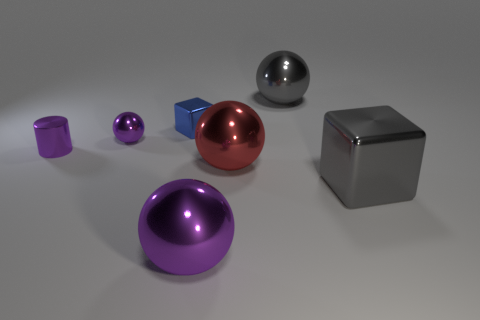What material is the gray thing that is the same shape as the large purple metallic thing?
Provide a succinct answer. Metal. How many gray shiny objects have the same shape as the big purple metallic object?
Keep it short and to the point. 1. Are there more tiny things on the left side of the tiny purple ball than tiny blocks that are right of the blue thing?
Offer a terse response. Yes. Is the size of the red sphere the same as the gray sphere?
Make the answer very short. Yes. The cube that is on the right side of the gray ball that is to the right of the small block is what color?
Provide a short and direct response. Gray. The small cube is what color?
Your response must be concise. Blue. Is there a matte cube of the same color as the tiny metal sphere?
Provide a short and direct response. No. Is the color of the large thing behind the small shiny ball the same as the big metal block?
Keep it short and to the point. Yes. What number of objects are either metal cubes that are behind the large red sphere or purple metal cylinders?
Provide a short and direct response. 2. There is a tiny purple metallic ball; are there any small purple objects in front of it?
Offer a terse response. Yes. 